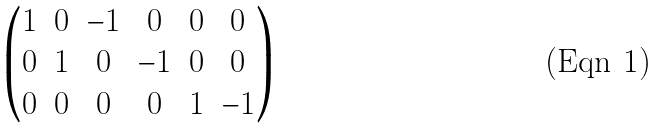Convert formula to latex. <formula><loc_0><loc_0><loc_500><loc_500>\begin{pmatrix} 1 & 0 & - 1 & 0 & 0 & 0 \\ 0 & 1 & 0 & - 1 & 0 & 0 \\ 0 & 0 & 0 & 0 & 1 & - 1 \\ \end{pmatrix}</formula> 